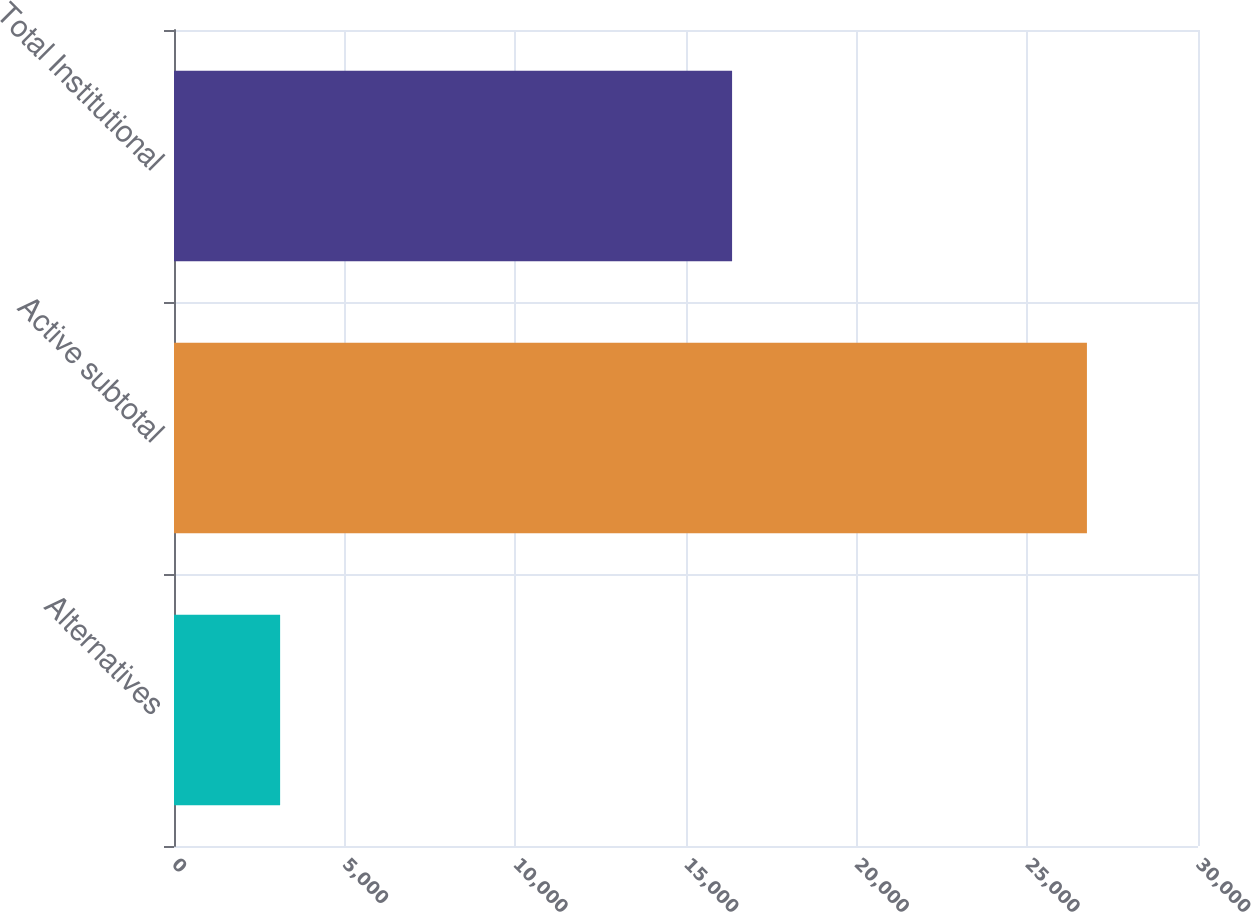Convert chart to OTSL. <chart><loc_0><loc_0><loc_500><loc_500><bar_chart><fcel>Alternatives<fcel>Active subtotal<fcel>Total Institutional<nl><fcel>3109<fcel>26746<fcel>16350<nl></chart> 